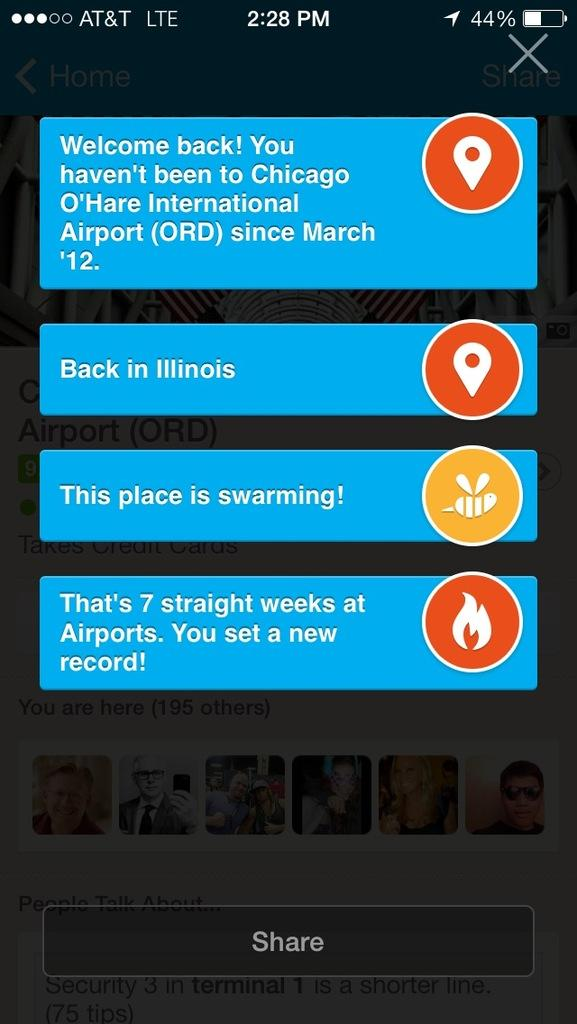Provide a one-sentence caption for the provided image. A screenshot of a cell phone shows a text conversation about Chicago, IL and being in airports a lot. 